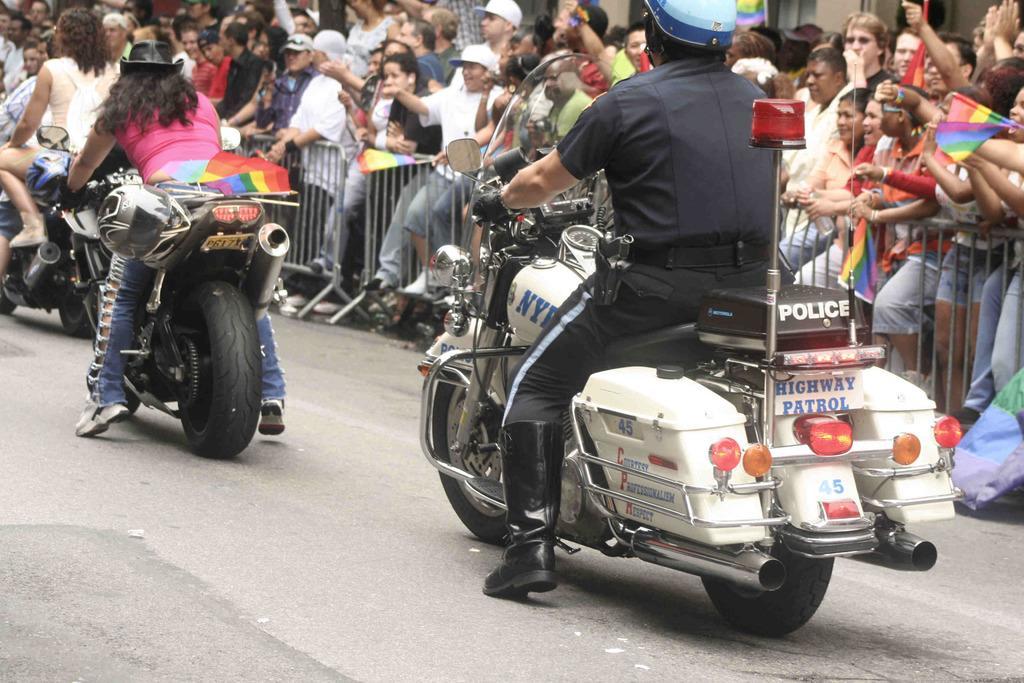Please provide a concise description of this image. This picture shows some of the people riding motorcycles, in the background there is barrel gates and group of people cheering for them, This man is wearing helmet and shoes. 